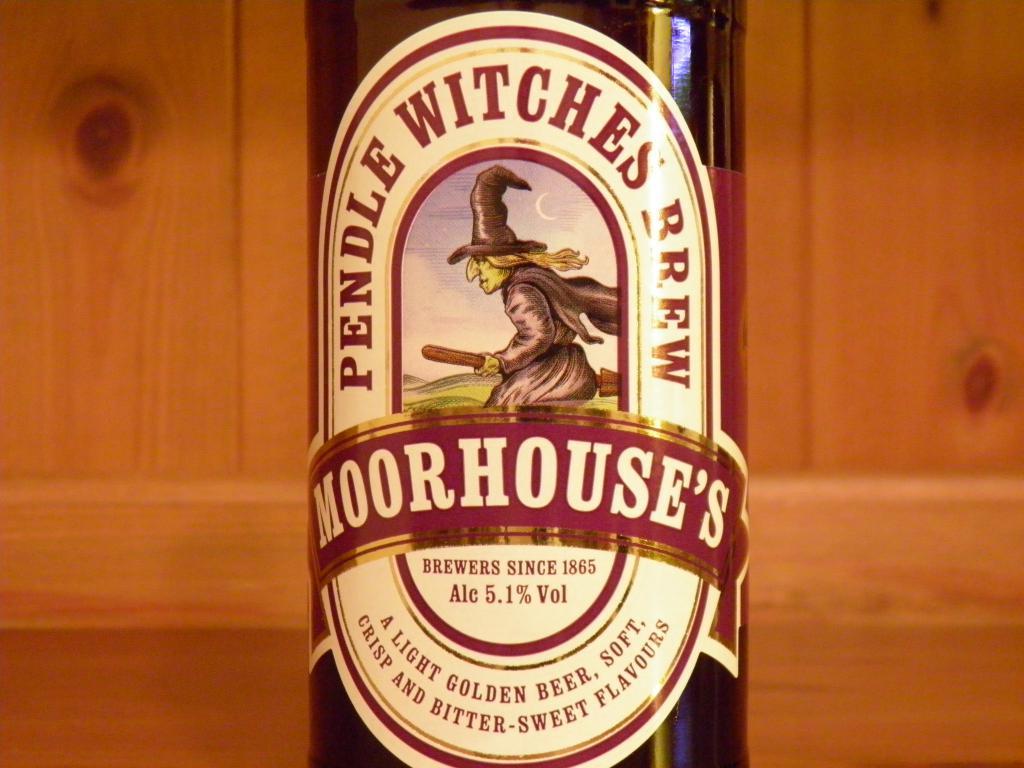What percentage of alcohol is in the beer?
Provide a short and direct response. 5.1. What brand of beer is this?
Keep it short and to the point. Moorhouse. 